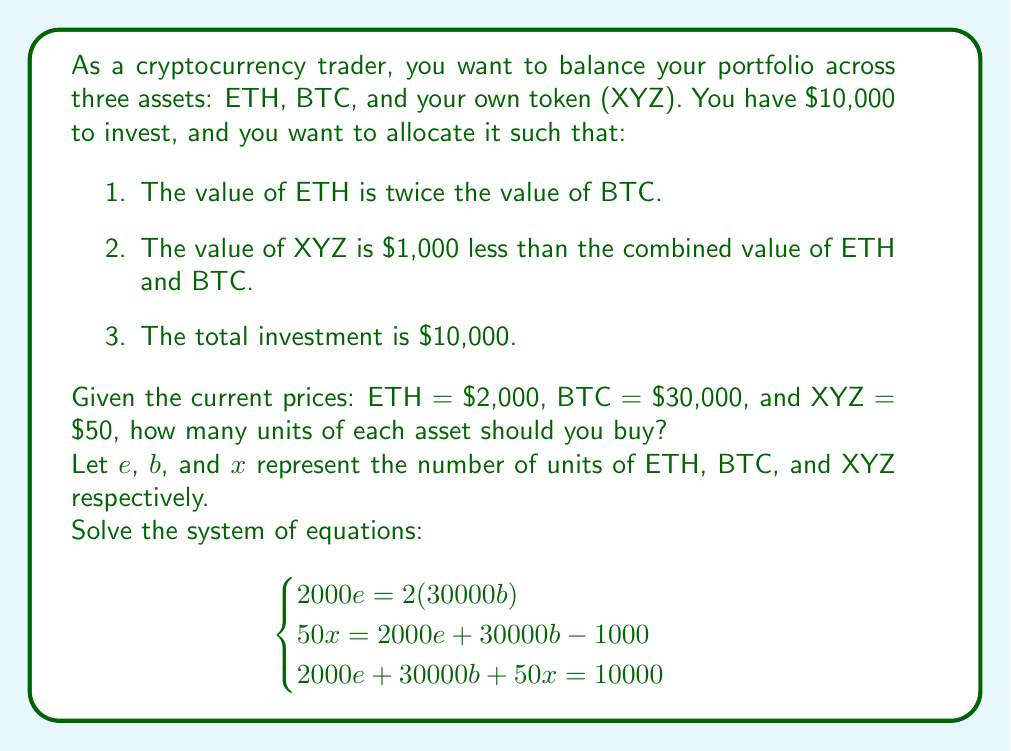Teach me how to tackle this problem. Let's solve this system of equations step by step:

1) From the first equation:
   $2000e = 2(30000b)$
   $2000e = 60000b$
   $e = 30b$ ... (Equation 1)

2) Substitute this into the second equation:
   $50x = 2000(30b) + 30000b - 1000$
   $50x = 60000b + 30000b - 1000$
   $50x = 90000b - 1000$ ... (Equation 2)

3) Now, let's use Equation 1 and Equation 2 in the third equation:
   $2000(30b) + 30000b + 50x = 10000$
   $60000b + 30000b + 50x = 10000$
   $90000b + 50x = 10000$ ... (Equation 3)

4) From Equation 2:
   $x = 1800b - 20$ ... (Equation 4)

5) Substitute Equation 4 into Equation 3:
   $90000b + 50(1800b - 20) = 10000$
   $90000b + 90000b - 1000 = 10000$
   $180000b = 11000$
   $b = 11000/180000 = 11/180$

6) Now we can find $e$ using Equation 1:
   $e = 30b = 30(11/180) = 11/6$

7) And $x$ using Equation 4:
   $x = 1800(11/180) - 20 = 110 - 20 = 90$

8) Let's verify:
   ETH: $(11/6) * 2000 = 3666.67$
   BTC: $(11/180) * 30000 = 1833.33$
   XYZ: $90 * 50 = 4500$
   Total: $3666.67 + 1833.33 + 4500 = 10000$

   This satisfies all conditions.
Answer: ETH: $11/6$ units, BTC: $11/180$ units, XYZ: $90$ units 